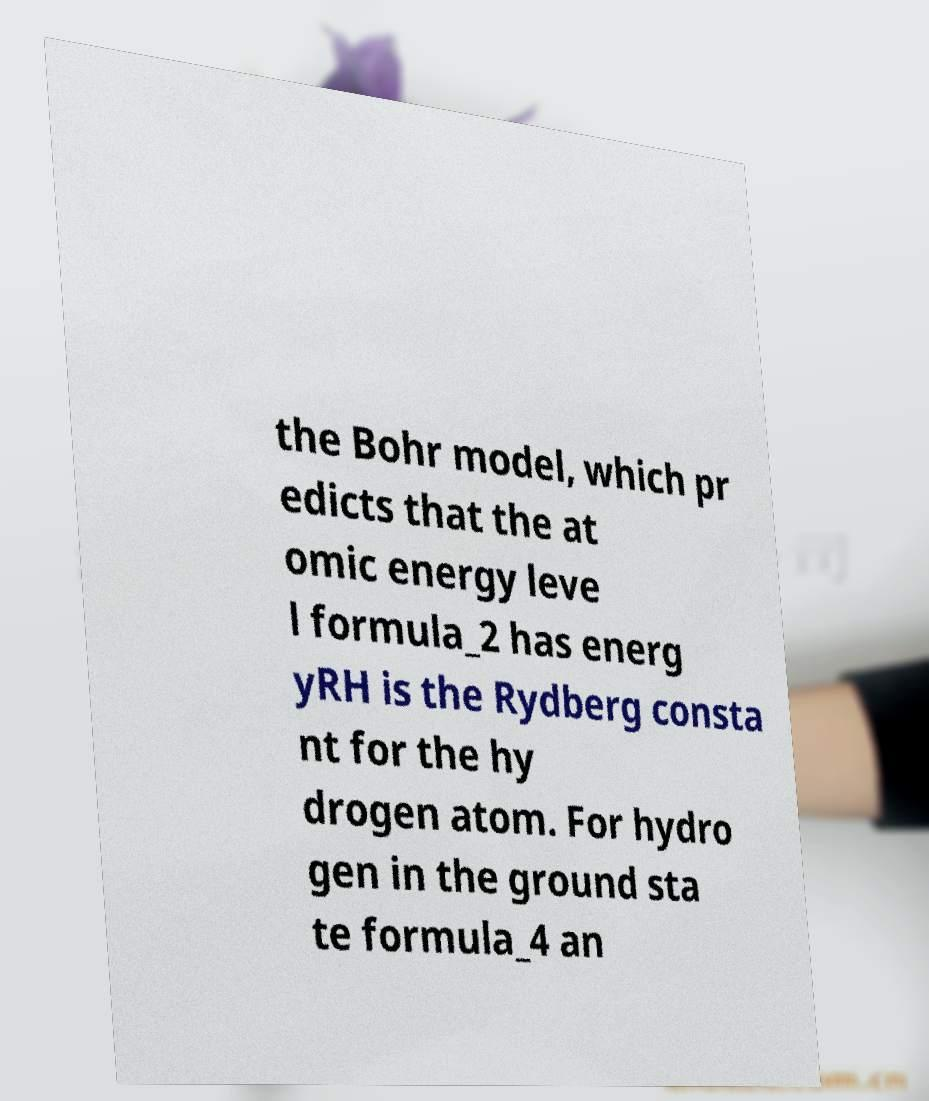Can you accurately transcribe the text from the provided image for me? the Bohr model, which pr edicts that the at omic energy leve l formula_2 has energ yRH is the Rydberg consta nt for the hy drogen atom. For hydro gen in the ground sta te formula_4 an 